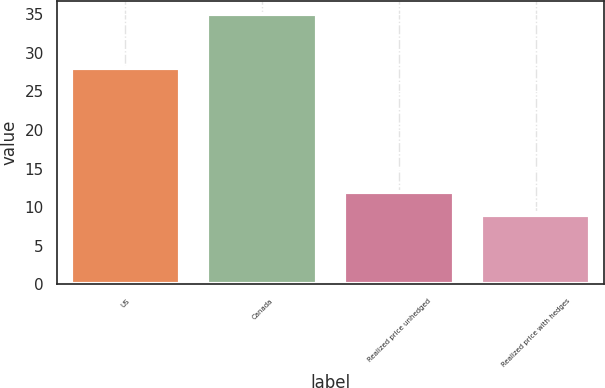<chart> <loc_0><loc_0><loc_500><loc_500><bar_chart><fcel>US<fcel>Canada<fcel>Realized price unhedged<fcel>Realized price with hedges<nl><fcel>28<fcel>35<fcel>12<fcel>9<nl></chart> 